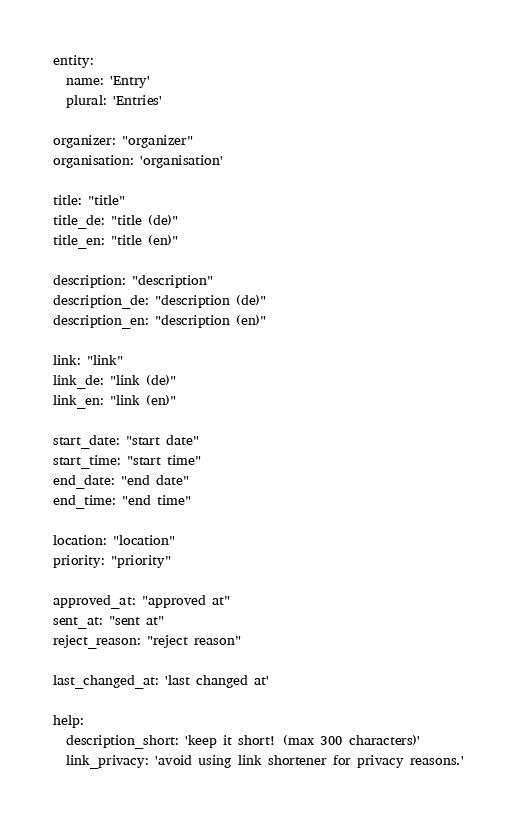<code> <loc_0><loc_0><loc_500><loc_500><_YAML_>entity:
  name: 'Entry'
  plural: 'Entries'

organizer: "organizer"
organisation: 'organisation'

title: "title"
title_de: "title (de)"
title_en: "title (en)"

description: "description"
description_de: "description (de)"
description_en: "description (en)"

link: "link"
link_de: "link (de)"
link_en: "link (en)"

start_date: "start date"
start_time: "start time"
end_date: "end date"
end_time: "end time"

location: "location"
priority: "priority"

approved_at: "approved at"
sent_at: "sent at"
reject_reason: "reject reason"

last_changed_at: 'last changed at'

help:
  description_short: 'keep it short! (max 300 characters)'
  link_privacy: 'avoid using link shortener for privacy reasons.'
</code> 